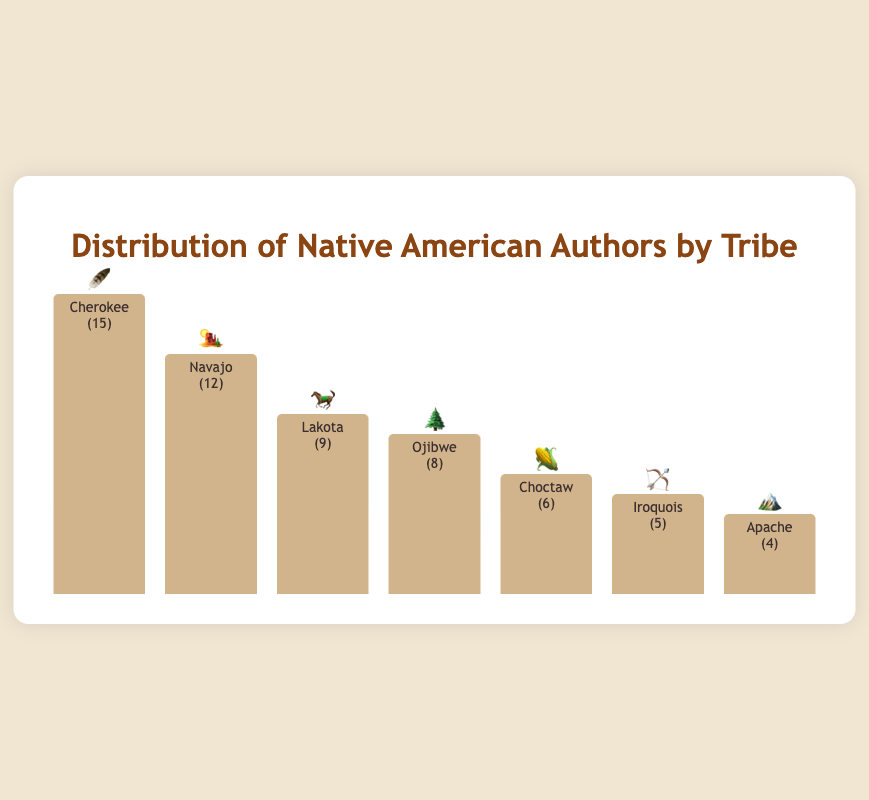What is the total number of Native American authors represented in the chart? Sum the number of authors from each tribe: 15 (Cherokee) + 12 (Navajo) + 9 (Lakota) + 8 (Ojibwe) + 6 (Choctaw) + 5 (Iroquois) + 4 (Apache) = 59
Answer: 59 Which tribe has the highest number of authors? Check the tribe with the tallest bar and highest value: Cherokee with 15 authors
Answer: Cherokee How many more authors are Cherokee compared to Apache? Subtract the number of Apache authors from Cherokee authors: 15 - 4 = 11
Answer: 11 Which tribes have fewer than 10 authors represented? Identify the tribes with bars shorter than the height corresponding to 10 authors: Ojibwe (8), Choctaw (6), Iroquois (5), Apache (4)
Answer: Ojibwe, Choctaw, Iroquois, Apache What's the average number of authors per tribe represented in the chart? Total number of authors (59) divided by the number of tribes (7): 59 / 7 ≈ 8.43
Answer: 8.43 How many tribes have more than 8 authors represented? Identify the tribes with bars taller than the height corresponding to 8 authors: Cherokee (15), Navajo (12), Lakota (9)
Answer: 3 Which tribe's authors are represented by the 🌽 emoji, and how many authors are there? Identify the tribe with 🌽 emoji: Choctaw with 6 authors
Answer: Choctaw, 6 What's the difference in the number of authors between Navajo and Ojibwe? Subtract the number of Ojibwe authors from Navajo authors: 12 - 8 = 4
Answer: 4 If we combine the authors from Iroquois and Apache tribes, how many authors would that be? Add the number of Iroquois authors and Apache authors: 5 + 4 = 9
Answer: 9 What is the median number of authors represented among the tribes? List the number of authors in ascending order: 4, 5, 6, 8, 9, 12, 15. The median is the middle value: 8
Answer: 8 